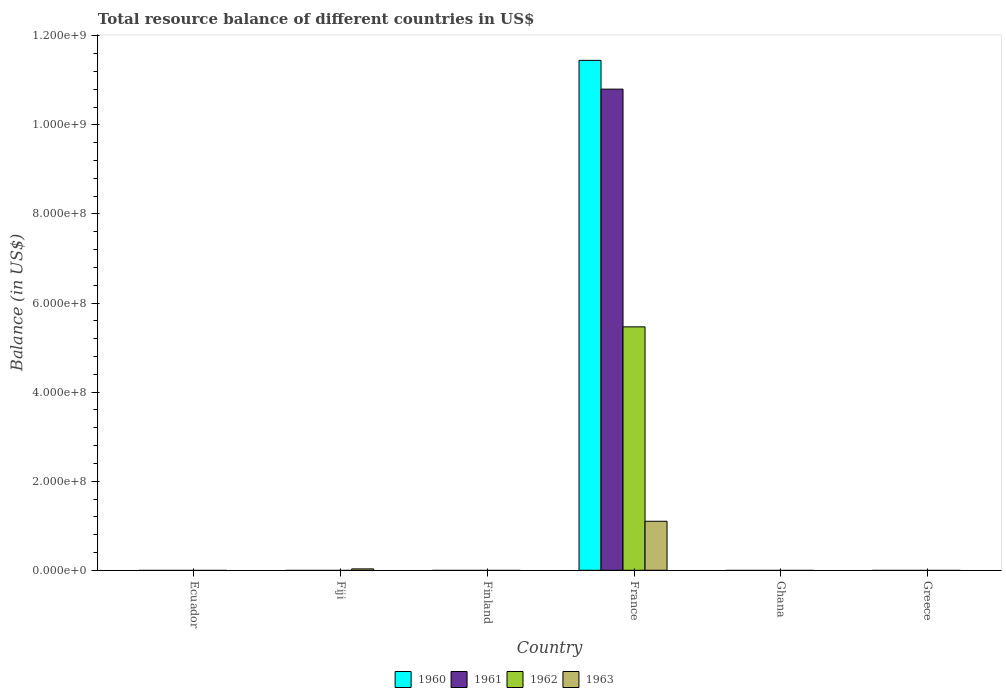Are the number of bars per tick equal to the number of legend labels?
Provide a succinct answer. No. How many bars are there on the 6th tick from the right?
Your response must be concise. 0. In how many cases, is the number of bars for a given country not equal to the number of legend labels?
Ensure brevity in your answer.  5. What is the total resource balance in 1963 in Greece?
Ensure brevity in your answer.  0. Across all countries, what is the maximum total resource balance in 1962?
Ensure brevity in your answer.  5.46e+08. Across all countries, what is the minimum total resource balance in 1960?
Provide a short and direct response. 0. In which country was the total resource balance in 1963 maximum?
Your answer should be very brief. France. What is the total total resource balance in 1961 in the graph?
Your answer should be compact. 1.08e+09. What is the difference between the total resource balance in 1963 in Ghana and the total resource balance in 1962 in Greece?
Ensure brevity in your answer.  0. What is the average total resource balance in 1961 per country?
Offer a terse response. 1.80e+08. In how many countries, is the total resource balance in 1961 greater than 1040000000 US$?
Give a very brief answer. 1. What is the difference between the highest and the lowest total resource balance in 1962?
Keep it short and to the point. 5.46e+08. In how many countries, is the total resource balance in 1963 greater than the average total resource balance in 1963 taken over all countries?
Give a very brief answer. 1. Is it the case that in every country, the sum of the total resource balance in 1961 and total resource balance in 1960 is greater than the sum of total resource balance in 1962 and total resource balance in 1963?
Offer a terse response. No. What is the difference between two consecutive major ticks on the Y-axis?
Give a very brief answer. 2.00e+08. Are the values on the major ticks of Y-axis written in scientific E-notation?
Make the answer very short. Yes. Does the graph contain grids?
Provide a short and direct response. No. Where does the legend appear in the graph?
Keep it short and to the point. Bottom center. How are the legend labels stacked?
Offer a terse response. Horizontal. What is the title of the graph?
Your response must be concise. Total resource balance of different countries in US$. Does "1969" appear as one of the legend labels in the graph?
Keep it short and to the point. No. What is the label or title of the X-axis?
Provide a succinct answer. Country. What is the label or title of the Y-axis?
Provide a short and direct response. Balance (in US$). What is the Balance (in US$) in 1960 in Ecuador?
Give a very brief answer. 0. What is the Balance (in US$) of 1962 in Ecuador?
Keep it short and to the point. 0. What is the Balance (in US$) of 1960 in Fiji?
Your answer should be very brief. 0. What is the Balance (in US$) in 1961 in Fiji?
Give a very brief answer. 0. What is the Balance (in US$) of 1962 in Fiji?
Give a very brief answer. 0. What is the Balance (in US$) in 1963 in Fiji?
Your answer should be compact. 3.15e+06. What is the Balance (in US$) of 1960 in Finland?
Make the answer very short. 0. What is the Balance (in US$) in 1961 in Finland?
Keep it short and to the point. 0. What is the Balance (in US$) in 1960 in France?
Provide a short and direct response. 1.14e+09. What is the Balance (in US$) of 1961 in France?
Ensure brevity in your answer.  1.08e+09. What is the Balance (in US$) in 1962 in France?
Your answer should be very brief. 5.46e+08. What is the Balance (in US$) of 1963 in France?
Your response must be concise. 1.10e+08. What is the Balance (in US$) in 1961 in Ghana?
Your response must be concise. 0. What is the Balance (in US$) in 1962 in Ghana?
Provide a succinct answer. 0. What is the Balance (in US$) of 1960 in Greece?
Your answer should be compact. 0. What is the Balance (in US$) of 1963 in Greece?
Provide a succinct answer. 0. Across all countries, what is the maximum Balance (in US$) of 1960?
Offer a terse response. 1.14e+09. Across all countries, what is the maximum Balance (in US$) of 1961?
Your answer should be compact. 1.08e+09. Across all countries, what is the maximum Balance (in US$) of 1962?
Offer a very short reply. 5.46e+08. Across all countries, what is the maximum Balance (in US$) in 1963?
Offer a terse response. 1.10e+08. Across all countries, what is the minimum Balance (in US$) in 1960?
Offer a terse response. 0. Across all countries, what is the minimum Balance (in US$) of 1961?
Your response must be concise. 0. Across all countries, what is the minimum Balance (in US$) of 1962?
Give a very brief answer. 0. Across all countries, what is the minimum Balance (in US$) in 1963?
Provide a short and direct response. 0. What is the total Balance (in US$) of 1960 in the graph?
Your answer should be compact. 1.14e+09. What is the total Balance (in US$) of 1961 in the graph?
Your answer should be compact. 1.08e+09. What is the total Balance (in US$) in 1962 in the graph?
Keep it short and to the point. 5.46e+08. What is the total Balance (in US$) of 1963 in the graph?
Offer a terse response. 1.13e+08. What is the difference between the Balance (in US$) in 1963 in Fiji and that in France?
Provide a short and direct response. -1.07e+08. What is the average Balance (in US$) of 1960 per country?
Ensure brevity in your answer.  1.91e+08. What is the average Balance (in US$) of 1961 per country?
Your response must be concise. 1.80e+08. What is the average Balance (in US$) of 1962 per country?
Keep it short and to the point. 9.11e+07. What is the average Balance (in US$) in 1963 per country?
Offer a terse response. 1.89e+07. What is the difference between the Balance (in US$) in 1960 and Balance (in US$) in 1961 in France?
Give a very brief answer. 6.46e+07. What is the difference between the Balance (in US$) of 1960 and Balance (in US$) of 1962 in France?
Your response must be concise. 5.98e+08. What is the difference between the Balance (in US$) of 1960 and Balance (in US$) of 1963 in France?
Your answer should be very brief. 1.03e+09. What is the difference between the Balance (in US$) in 1961 and Balance (in US$) in 1962 in France?
Your answer should be compact. 5.34e+08. What is the difference between the Balance (in US$) of 1961 and Balance (in US$) of 1963 in France?
Give a very brief answer. 9.70e+08. What is the difference between the Balance (in US$) of 1962 and Balance (in US$) of 1963 in France?
Provide a succinct answer. 4.36e+08. What is the ratio of the Balance (in US$) in 1963 in Fiji to that in France?
Your answer should be very brief. 0.03. What is the difference between the highest and the lowest Balance (in US$) in 1960?
Offer a terse response. 1.14e+09. What is the difference between the highest and the lowest Balance (in US$) of 1961?
Ensure brevity in your answer.  1.08e+09. What is the difference between the highest and the lowest Balance (in US$) in 1962?
Offer a very short reply. 5.46e+08. What is the difference between the highest and the lowest Balance (in US$) in 1963?
Make the answer very short. 1.10e+08. 